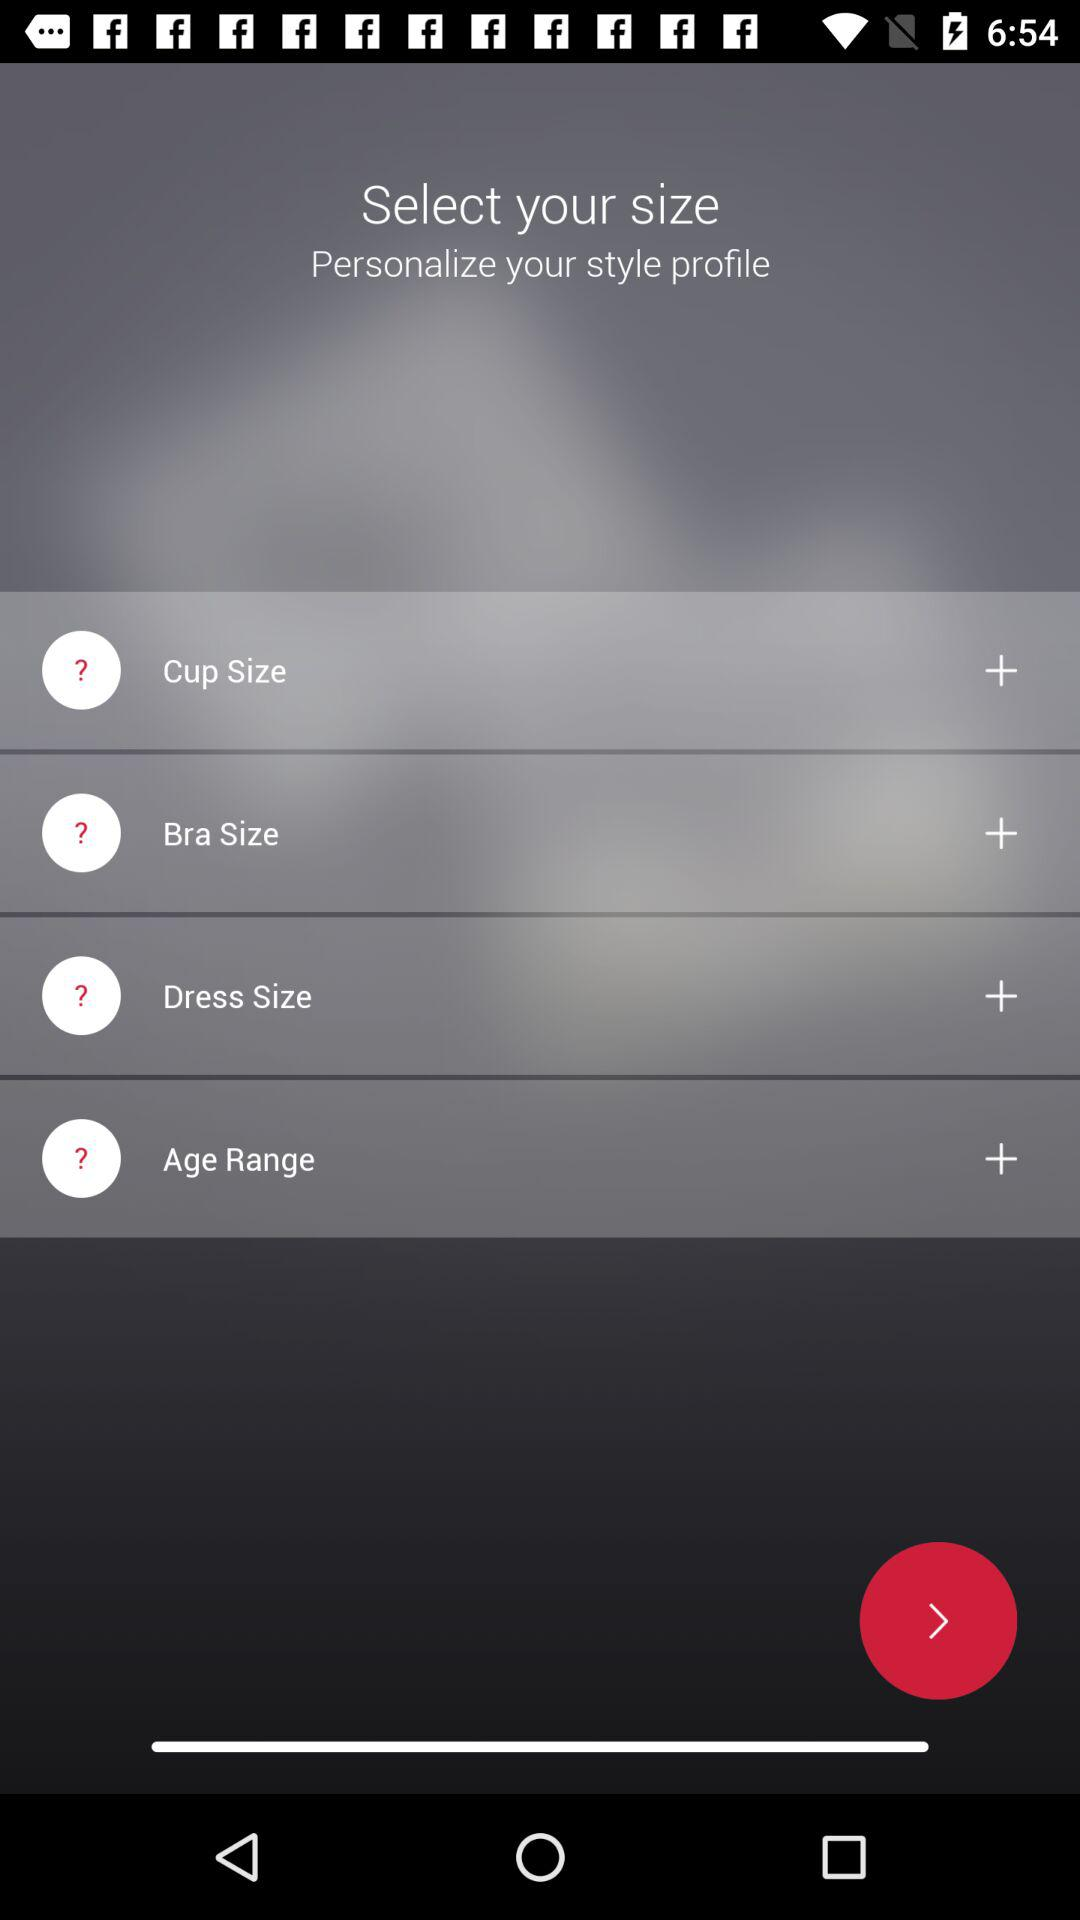How many size options are there?
Answer the question using a single word or phrase. 4 